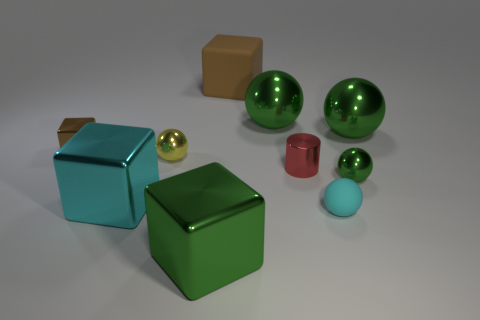Subtract all small blocks. How many blocks are left? 3 Subtract all cyan balls. How many balls are left? 4 Subtract 3 balls. How many balls are left? 2 Subtract all blocks. How many objects are left? 6 Subtract all blue cylinders. Subtract all cyan balls. How many cylinders are left? 1 Subtract all blue blocks. How many gray cylinders are left? 0 Subtract all cyan metal cubes. Subtract all big purple metallic things. How many objects are left? 9 Add 6 metal cylinders. How many metal cylinders are left? 7 Add 9 large cylinders. How many large cylinders exist? 9 Subtract 0 blue cylinders. How many objects are left? 10 